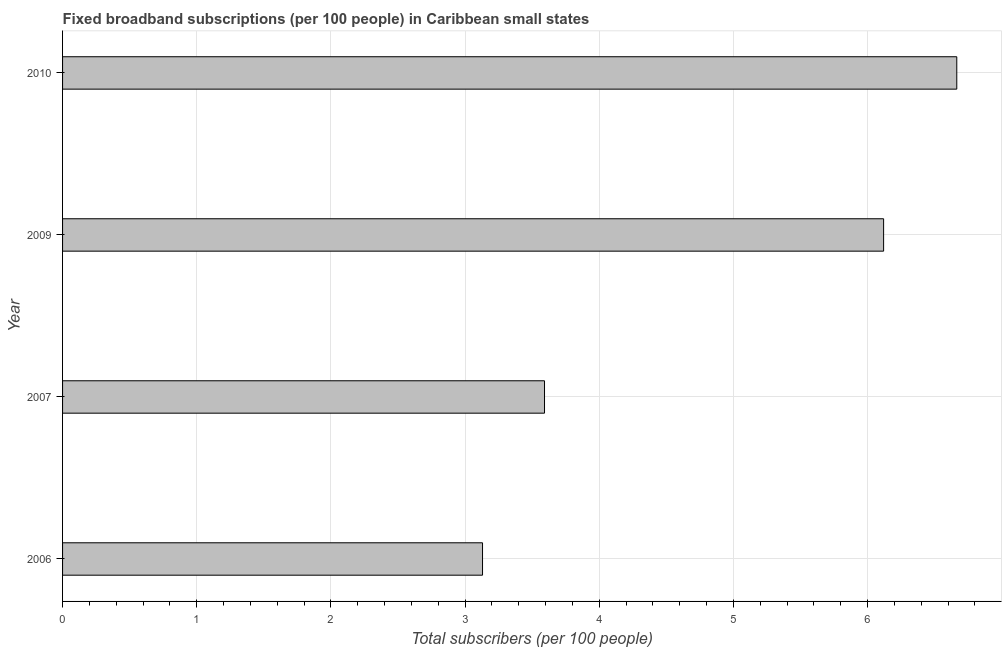Does the graph contain any zero values?
Your answer should be very brief. No. Does the graph contain grids?
Keep it short and to the point. Yes. What is the title of the graph?
Keep it short and to the point. Fixed broadband subscriptions (per 100 people) in Caribbean small states. What is the label or title of the X-axis?
Ensure brevity in your answer.  Total subscribers (per 100 people). What is the label or title of the Y-axis?
Provide a succinct answer. Year. What is the total number of fixed broadband subscriptions in 2009?
Make the answer very short. 6.12. Across all years, what is the maximum total number of fixed broadband subscriptions?
Your response must be concise. 6.66. Across all years, what is the minimum total number of fixed broadband subscriptions?
Provide a short and direct response. 3.13. In which year was the total number of fixed broadband subscriptions minimum?
Offer a very short reply. 2006. What is the sum of the total number of fixed broadband subscriptions?
Your response must be concise. 19.51. What is the difference between the total number of fixed broadband subscriptions in 2007 and 2010?
Give a very brief answer. -3.07. What is the average total number of fixed broadband subscriptions per year?
Keep it short and to the point. 4.88. What is the median total number of fixed broadband subscriptions?
Keep it short and to the point. 4.86. In how many years, is the total number of fixed broadband subscriptions greater than 4.4 ?
Offer a very short reply. 2. What is the ratio of the total number of fixed broadband subscriptions in 2006 to that in 2009?
Your answer should be very brief. 0.51. What is the difference between the highest and the second highest total number of fixed broadband subscriptions?
Your answer should be very brief. 0.55. Is the sum of the total number of fixed broadband subscriptions in 2006 and 2009 greater than the maximum total number of fixed broadband subscriptions across all years?
Offer a terse response. Yes. What is the difference between the highest and the lowest total number of fixed broadband subscriptions?
Your answer should be compact. 3.53. How many bars are there?
Offer a terse response. 4. What is the difference between two consecutive major ticks on the X-axis?
Give a very brief answer. 1. What is the Total subscribers (per 100 people) of 2006?
Keep it short and to the point. 3.13. What is the Total subscribers (per 100 people) of 2007?
Ensure brevity in your answer.  3.59. What is the Total subscribers (per 100 people) of 2009?
Your response must be concise. 6.12. What is the Total subscribers (per 100 people) of 2010?
Provide a short and direct response. 6.66. What is the difference between the Total subscribers (per 100 people) in 2006 and 2007?
Offer a very short reply. -0.46. What is the difference between the Total subscribers (per 100 people) in 2006 and 2009?
Provide a succinct answer. -2.99. What is the difference between the Total subscribers (per 100 people) in 2006 and 2010?
Provide a succinct answer. -3.53. What is the difference between the Total subscribers (per 100 people) in 2007 and 2009?
Ensure brevity in your answer.  -2.53. What is the difference between the Total subscribers (per 100 people) in 2007 and 2010?
Keep it short and to the point. -3.07. What is the difference between the Total subscribers (per 100 people) in 2009 and 2010?
Your answer should be very brief. -0.55. What is the ratio of the Total subscribers (per 100 people) in 2006 to that in 2007?
Offer a terse response. 0.87. What is the ratio of the Total subscribers (per 100 people) in 2006 to that in 2009?
Ensure brevity in your answer.  0.51. What is the ratio of the Total subscribers (per 100 people) in 2006 to that in 2010?
Make the answer very short. 0.47. What is the ratio of the Total subscribers (per 100 people) in 2007 to that in 2009?
Provide a short and direct response. 0.59. What is the ratio of the Total subscribers (per 100 people) in 2007 to that in 2010?
Keep it short and to the point. 0.54. What is the ratio of the Total subscribers (per 100 people) in 2009 to that in 2010?
Offer a terse response. 0.92. 